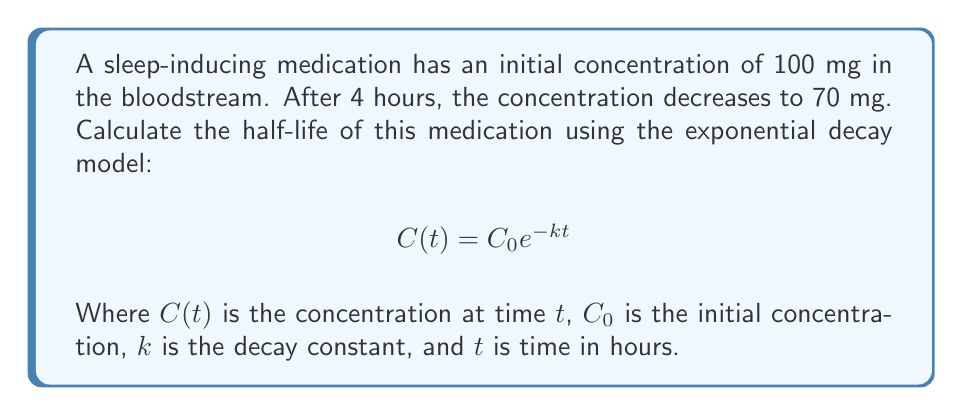Solve this math problem. 1) We know:
   $C_0 = 100$ mg
   $C(4) = 70$ mg
   $t = 4$ hours

2) Substitute these values into the exponential decay equation:
   $$70 = 100 e^{-4k}$$

3) Divide both sides by 100:
   $$0.7 = e^{-4k}$$

4) Take the natural logarithm of both sides:
   $$\ln(0.7) = -4k$$

5) Solve for $k$:
   $$k = -\frac{\ln(0.7)}{4} \approx 0.0888$$

6) The half-life $t_{1/2}$ is the time it takes for the concentration to decrease by half. It's related to $k$ by:
   $$t_{1/2} = \frac{\ln(2)}{k}$$

7) Substitute the value of $k$:
   $$t_{1/2} = \frac{\ln(2)}{0.0888} \approx 7.80$$

Therefore, the half-life of the medication is approximately 7.80 hours.
Answer: 7.80 hours 